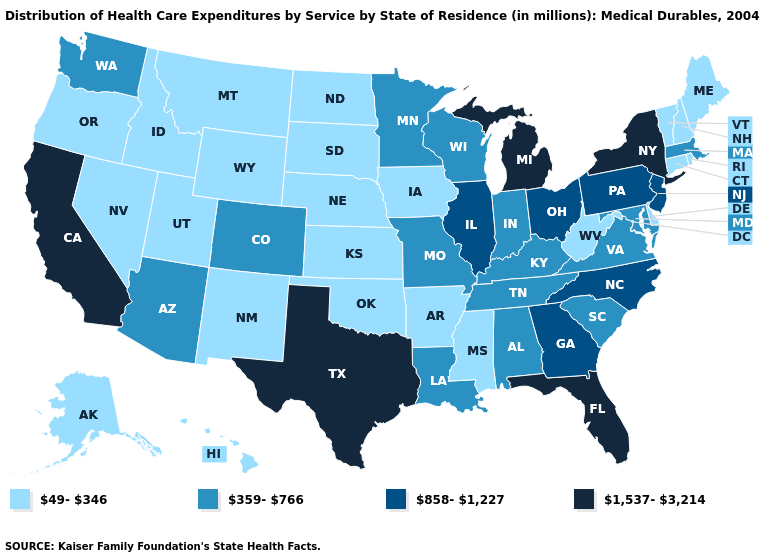What is the highest value in the USA?
Answer briefly. 1,537-3,214. Name the states that have a value in the range 49-346?
Short answer required. Alaska, Arkansas, Connecticut, Delaware, Hawaii, Idaho, Iowa, Kansas, Maine, Mississippi, Montana, Nebraska, Nevada, New Hampshire, New Mexico, North Dakota, Oklahoma, Oregon, Rhode Island, South Dakota, Utah, Vermont, West Virginia, Wyoming. Which states have the lowest value in the USA?
Keep it brief. Alaska, Arkansas, Connecticut, Delaware, Hawaii, Idaho, Iowa, Kansas, Maine, Mississippi, Montana, Nebraska, Nevada, New Hampshire, New Mexico, North Dakota, Oklahoma, Oregon, Rhode Island, South Dakota, Utah, Vermont, West Virginia, Wyoming. What is the lowest value in the West?
Keep it brief. 49-346. Does Massachusetts have the lowest value in the USA?
Answer briefly. No. How many symbols are there in the legend?
Be succinct. 4. What is the value of Mississippi?
Answer briefly. 49-346. Does Virginia have the same value as Colorado?
Give a very brief answer. Yes. Name the states that have a value in the range 49-346?
Concise answer only. Alaska, Arkansas, Connecticut, Delaware, Hawaii, Idaho, Iowa, Kansas, Maine, Mississippi, Montana, Nebraska, Nevada, New Hampshire, New Mexico, North Dakota, Oklahoma, Oregon, Rhode Island, South Dakota, Utah, Vermont, West Virginia, Wyoming. How many symbols are there in the legend?
Quick response, please. 4. Does South Carolina have the same value as Missouri?
Give a very brief answer. Yes. What is the highest value in states that border Massachusetts?
Answer briefly. 1,537-3,214. What is the value of Tennessee?
Quick response, please. 359-766. Name the states that have a value in the range 858-1,227?
Be succinct. Georgia, Illinois, New Jersey, North Carolina, Ohio, Pennsylvania. What is the lowest value in the South?
Write a very short answer. 49-346. 